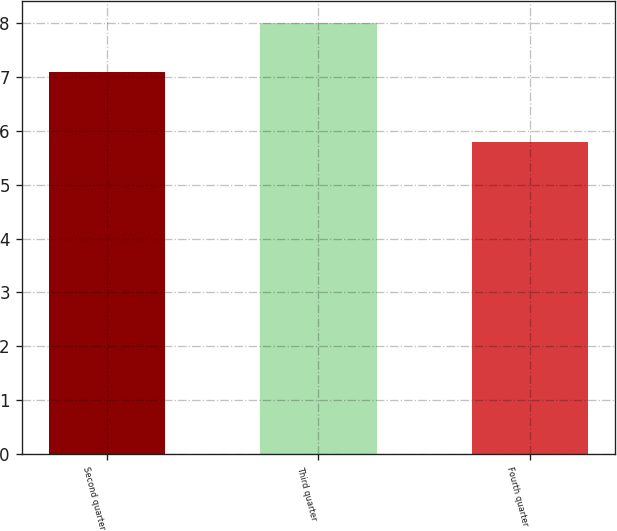Convert chart. <chart><loc_0><loc_0><loc_500><loc_500><bar_chart><fcel>Second quarter<fcel>Third quarter<fcel>Fourth quarter<nl><fcel>7.09<fcel>8<fcel>5.8<nl></chart> 